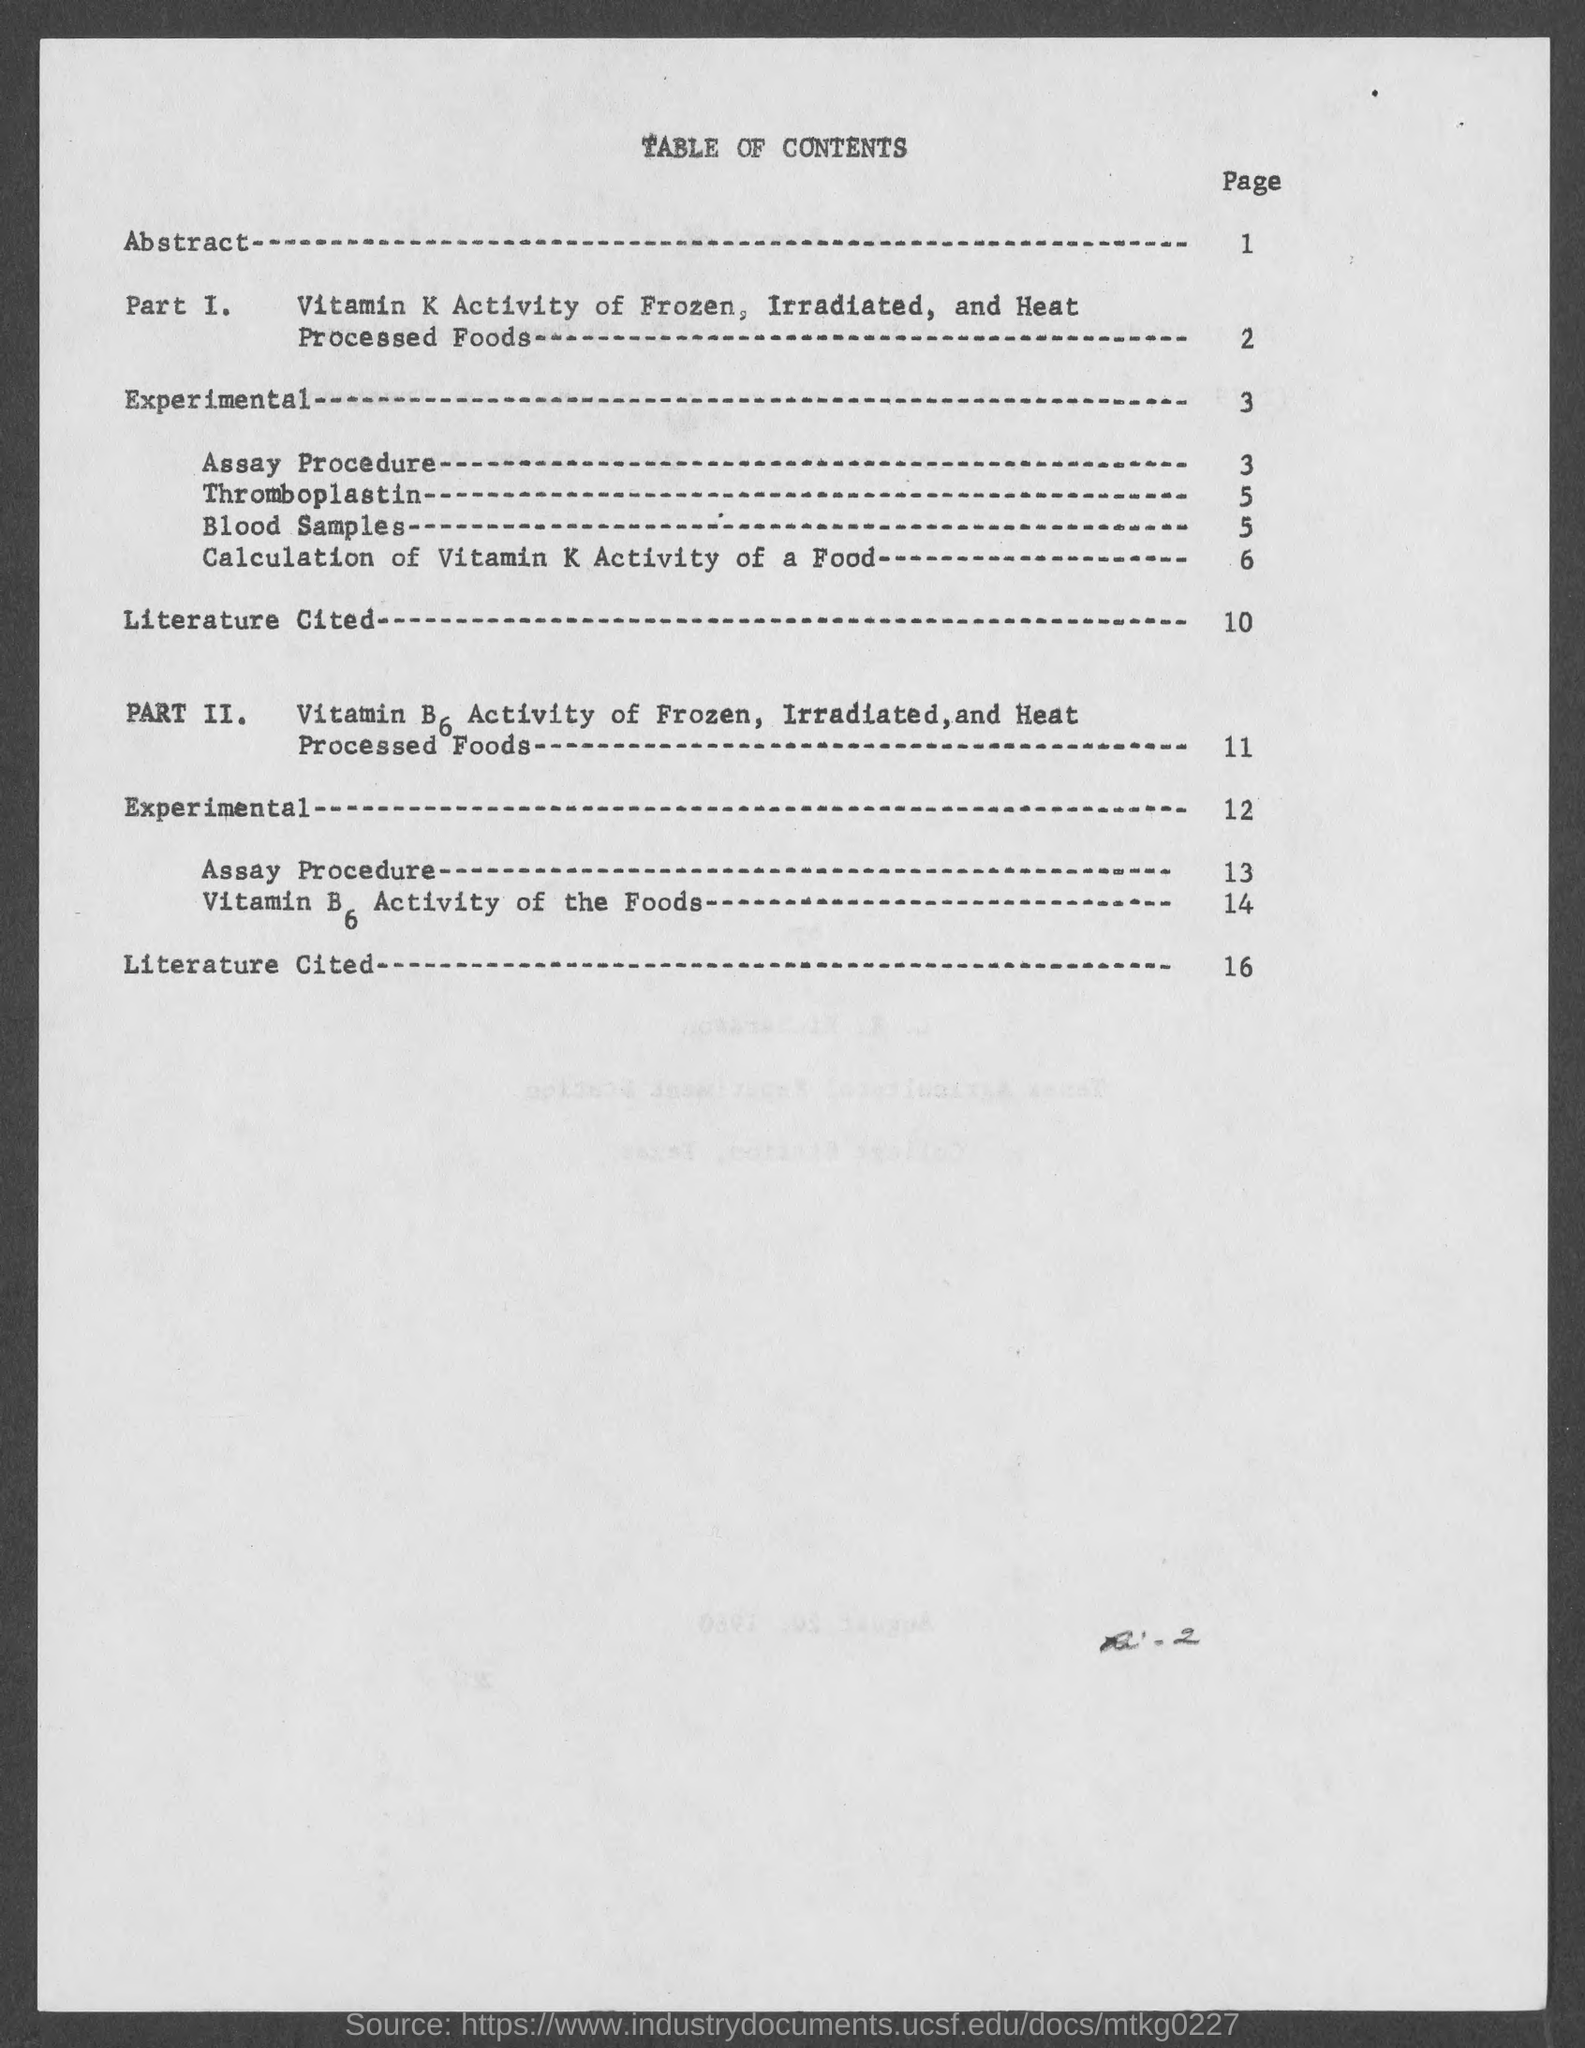Give some essential details in this illustration. The requested information for blood samples can be found on page 5. The information regarding the calculation of vitamin K activity in a food can be found on page 6. The page number of the abstract is 1. The title of the page is "Table of Contents. The page number for Thromboplastin is 5. 